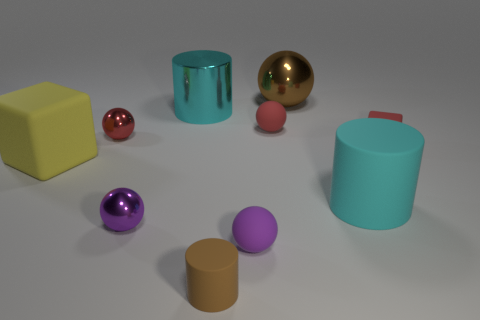Subtract all big balls. How many balls are left? 4 Subtract all brown balls. How many balls are left? 4 Subtract all blue balls. Subtract all blue cylinders. How many balls are left? 5 Subtract all cylinders. How many objects are left? 7 Add 8 blocks. How many blocks exist? 10 Subtract 0 blue blocks. How many objects are left? 10 Subtract all brown shiny objects. Subtract all cyan things. How many objects are left? 7 Add 7 tiny rubber blocks. How many tiny rubber blocks are left? 8 